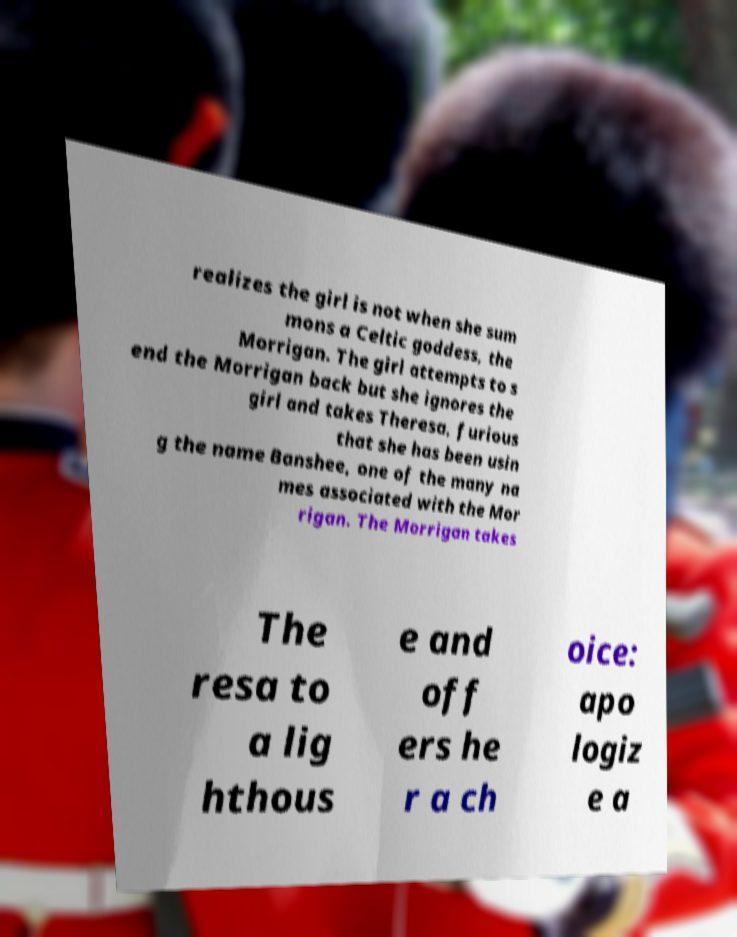Can you accurately transcribe the text from the provided image for me? realizes the girl is not when she sum mons a Celtic goddess, the Morrigan. The girl attempts to s end the Morrigan back but she ignores the girl and takes Theresa, furious that she has been usin g the name Banshee, one of the many na mes associated with the Mor rigan. The Morrigan takes The resa to a lig hthous e and off ers he r a ch oice: apo logiz e a 